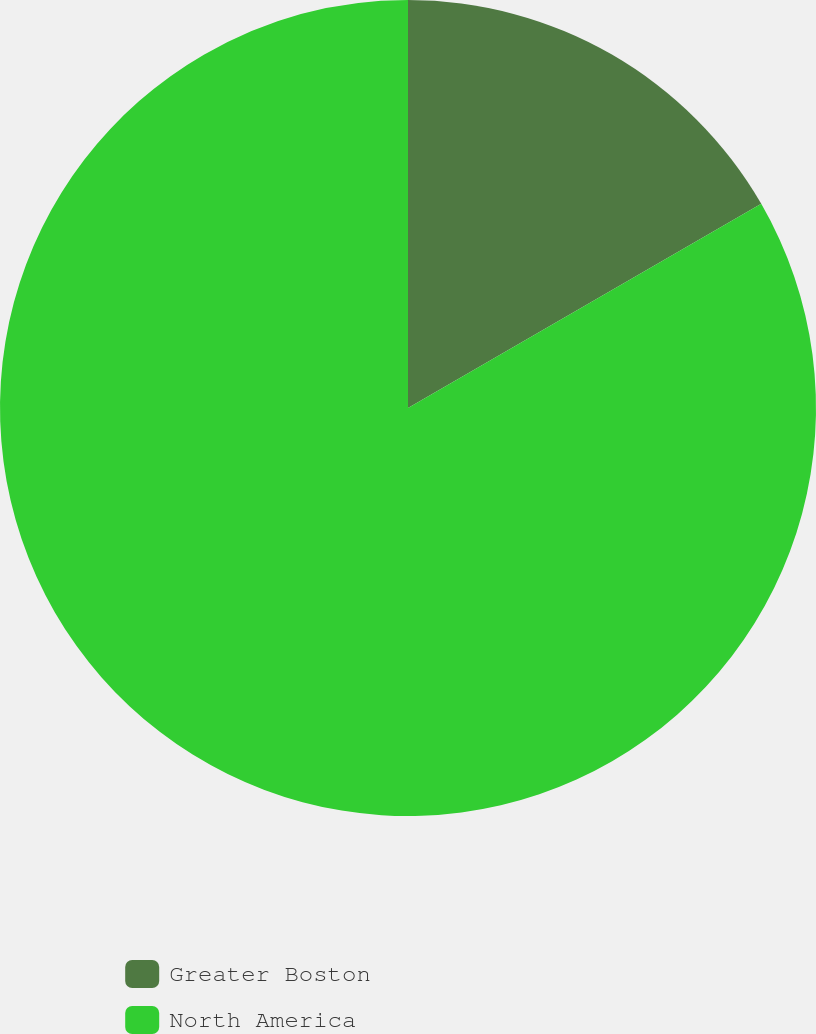Convert chart to OTSL. <chart><loc_0><loc_0><loc_500><loc_500><pie_chart><fcel>Greater Boston<fcel>North America<nl><fcel>16.66%<fcel>83.34%<nl></chart> 